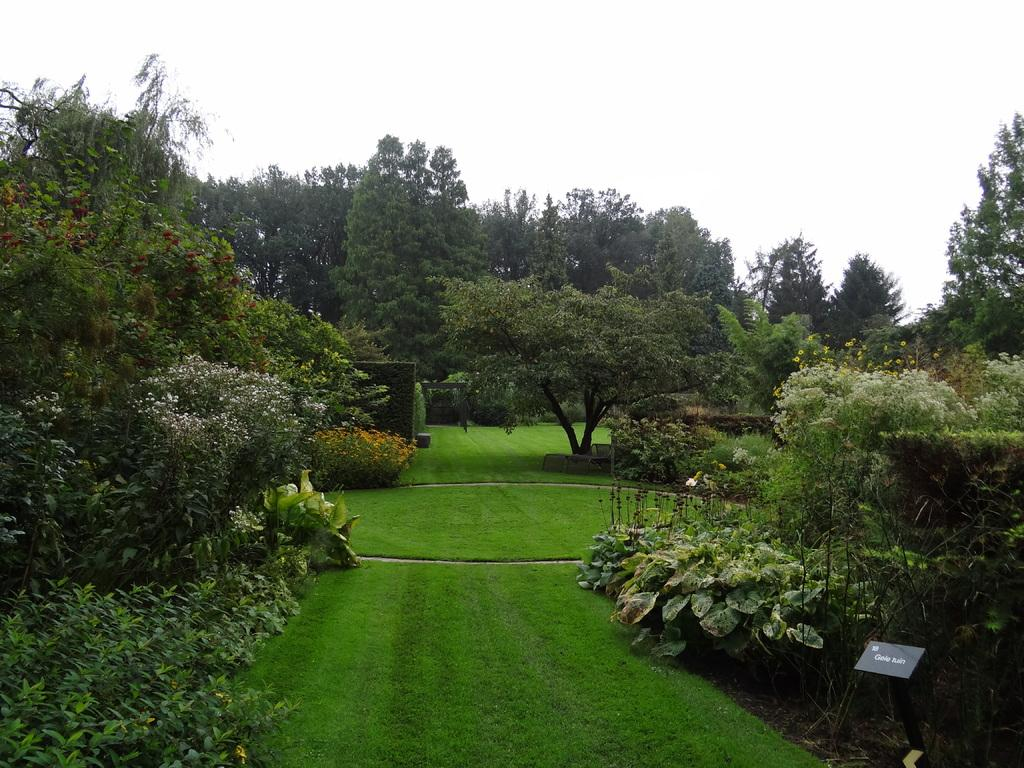What can be seen in the background of the image? The sky is visible in the background of the image. What type of vegetation is present in the image? There are trees, plants, and grass in the image. Can you describe the object on the right side of the image? Unfortunately, the facts provided do not give any information about the object on the right side of the image. What type of butter is being used to create a reaction with the tree in the image? There is no tree or butter present in the image, so it is not possible to answer that question. 